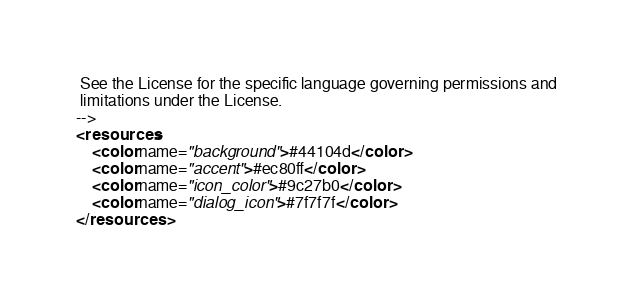<code> <loc_0><loc_0><loc_500><loc_500><_XML_> See the License for the specific language governing permissions and
 limitations under the License.
-->
<resources>
    <color name="background">#44104d</color>
    <color name="accent">#ec80ff</color>
    <color name="icon_color">#9c27b0</color>
    <color name="dialog_icon">#7f7f7f</color>
</resources></code> 